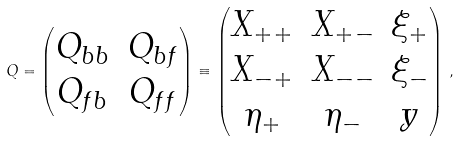<formula> <loc_0><loc_0><loc_500><loc_500>Q = \begin{pmatrix} Q _ { b b } & Q _ { b f } \\ Q _ { f b } & Q _ { f f } \end{pmatrix} \equiv \begin{pmatrix} X _ { + + } & X _ { + - } & \xi _ { + } \\ X _ { - + } & X _ { - - } & \xi _ { - } \\ \eta _ { + } & \eta _ { - } & y \end{pmatrix} \, ,</formula> 